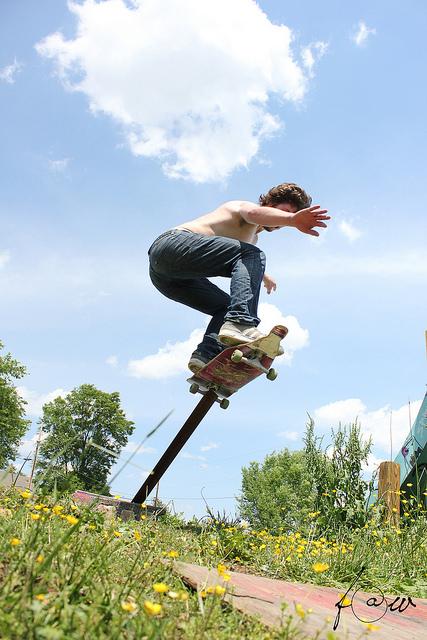What is he doing?
Quick response, please. Skateboarding. Is he a daredevil?
Give a very brief answer. Yes. How old is this guy?
Short answer required. 16. 